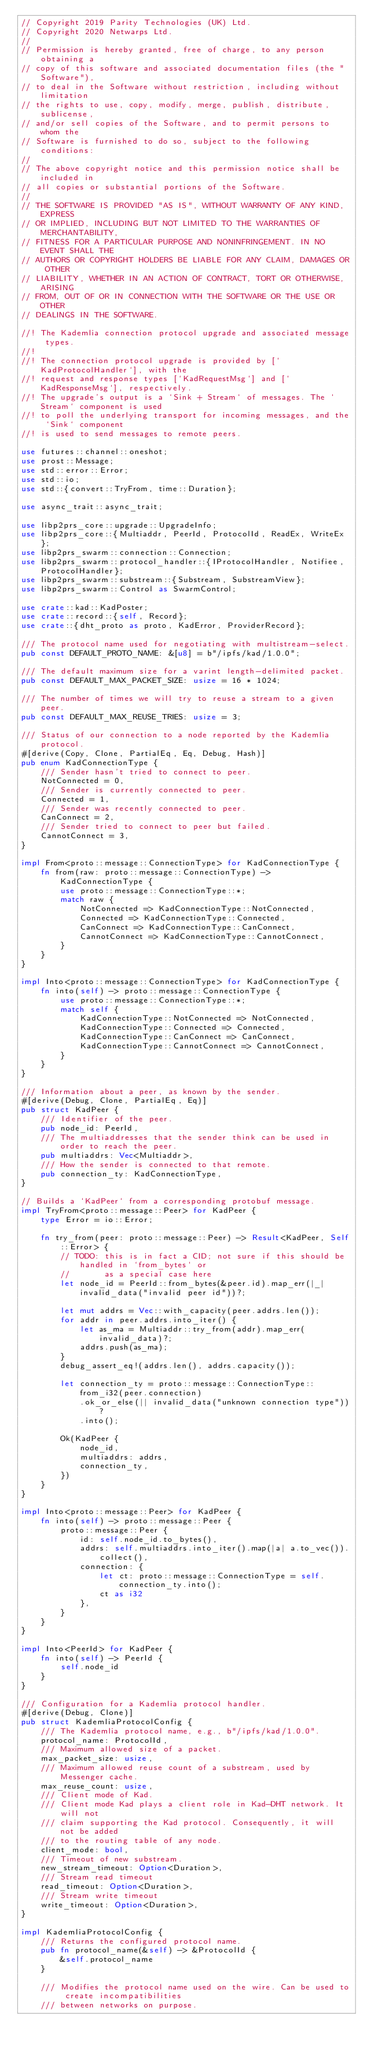<code> <loc_0><loc_0><loc_500><loc_500><_Rust_>// Copyright 2019 Parity Technologies (UK) Ltd.
// Copyright 2020 Netwarps Ltd.
//
// Permission is hereby granted, free of charge, to any person obtaining a
// copy of this software and associated documentation files (the "Software"),
// to deal in the Software without restriction, including without limitation
// the rights to use, copy, modify, merge, publish, distribute, sublicense,
// and/or sell copies of the Software, and to permit persons to whom the
// Software is furnished to do so, subject to the following conditions:
//
// The above copyright notice and this permission notice shall be included in
// all copies or substantial portions of the Software.
//
// THE SOFTWARE IS PROVIDED "AS IS", WITHOUT WARRANTY OF ANY KIND, EXPRESS
// OR IMPLIED, INCLUDING BUT NOT LIMITED TO THE WARRANTIES OF MERCHANTABILITY,
// FITNESS FOR A PARTICULAR PURPOSE AND NONINFRINGEMENT. IN NO EVENT SHALL THE
// AUTHORS OR COPYRIGHT HOLDERS BE LIABLE FOR ANY CLAIM, DAMAGES OR OTHER
// LIABILITY, WHETHER IN AN ACTION OF CONTRACT, TORT OR OTHERWISE, ARISING
// FROM, OUT OF OR IN CONNECTION WITH THE SOFTWARE OR THE USE OR OTHER
// DEALINGS IN THE SOFTWARE.

//! The Kademlia connection protocol upgrade and associated message types.
//!
//! The connection protocol upgrade is provided by [`KadProtocolHandler`], with the
//! request and response types [`KadRequestMsg`] and [`KadResponseMsg`], respectively.
//! The upgrade's output is a `Sink + Stream` of messages. The `Stream` component is used
//! to poll the underlying transport for incoming messages, and the `Sink` component
//! is used to send messages to remote peers.

use futures::channel::oneshot;
use prost::Message;
use std::error::Error;
use std::io;
use std::{convert::TryFrom, time::Duration};

use async_trait::async_trait;

use libp2prs_core::upgrade::UpgradeInfo;
use libp2prs_core::{Multiaddr, PeerId, ProtocolId, ReadEx, WriteEx};
use libp2prs_swarm::connection::Connection;
use libp2prs_swarm::protocol_handler::{IProtocolHandler, Notifiee, ProtocolHandler};
use libp2prs_swarm::substream::{Substream, SubstreamView};
use libp2prs_swarm::Control as SwarmControl;

use crate::kad::KadPoster;
use crate::record::{self, Record};
use crate::{dht_proto as proto, KadError, ProviderRecord};

/// The protocol name used for negotiating with multistream-select.
pub const DEFAULT_PROTO_NAME: &[u8] = b"/ipfs/kad/1.0.0";

/// The default maximum size for a varint length-delimited packet.
pub const DEFAULT_MAX_PACKET_SIZE: usize = 16 * 1024;

/// The number of times we will try to reuse a stream to a given peer.
pub const DEFAULT_MAX_REUSE_TRIES: usize = 3;

/// Status of our connection to a node reported by the Kademlia protocol.
#[derive(Copy, Clone, PartialEq, Eq, Debug, Hash)]
pub enum KadConnectionType {
    /// Sender hasn't tried to connect to peer.
    NotConnected = 0,
    /// Sender is currently connected to peer.
    Connected = 1,
    /// Sender was recently connected to peer.
    CanConnect = 2,
    /// Sender tried to connect to peer but failed.
    CannotConnect = 3,
}

impl From<proto::message::ConnectionType> for KadConnectionType {
    fn from(raw: proto::message::ConnectionType) -> KadConnectionType {
        use proto::message::ConnectionType::*;
        match raw {
            NotConnected => KadConnectionType::NotConnected,
            Connected => KadConnectionType::Connected,
            CanConnect => KadConnectionType::CanConnect,
            CannotConnect => KadConnectionType::CannotConnect,
        }
    }
}

impl Into<proto::message::ConnectionType> for KadConnectionType {
    fn into(self) -> proto::message::ConnectionType {
        use proto::message::ConnectionType::*;
        match self {
            KadConnectionType::NotConnected => NotConnected,
            KadConnectionType::Connected => Connected,
            KadConnectionType::CanConnect => CanConnect,
            KadConnectionType::CannotConnect => CannotConnect,
        }
    }
}

/// Information about a peer, as known by the sender.
#[derive(Debug, Clone, PartialEq, Eq)]
pub struct KadPeer {
    /// Identifier of the peer.
    pub node_id: PeerId,
    /// The multiaddresses that the sender think can be used in order to reach the peer.
    pub multiaddrs: Vec<Multiaddr>,
    /// How the sender is connected to that remote.
    pub connection_ty: KadConnectionType,
}

// Builds a `KadPeer` from a corresponding protobuf message.
impl TryFrom<proto::message::Peer> for KadPeer {
    type Error = io::Error;

    fn try_from(peer: proto::message::Peer) -> Result<KadPeer, Self::Error> {
        // TODO: this is in fact a CID; not sure if this should be handled in `from_bytes` or
        //       as a special case here
        let node_id = PeerId::from_bytes(&peer.id).map_err(|_| invalid_data("invalid peer id"))?;

        let mut addrs = Vec::with_capacity(peer.addrs.len());
        for addr in peer.addrs.into_iter() {
            let as_ma = Multiaddr::try_from(addr).map_err(invalid_data)?;
            addrs.push(as_ma);
        }
        debug_assert_eq!(addrs.len(), addrs.capacity());

        let connection_ty = proto::message::ConnectionType::from_i32(peer.connection)
            .ok_or_else(|| invalid_data("unknown connection type"))?
            .into();

        Ok(KadPeer {
            node_id,
            multiaddrs: addrs,
            connection_ty,
        })
    }
}

impl Into<proto::message::Peer> for KadPeer {
    fn into(self) -> proto::message::Peer {
        proto::message::Peer {
            id: self.node_id.to_bytes(),
            addrs: self.multiaddrs.into_iter().map(|a| a.to_vec()).collect(),
            connection: {
                let ct: proto::message::ConnectionType = self.connection_ty.into();
                ct as i32
            },
        }
    }
}

impl Into<PeerId> for KadPeer {
    fn into(self) -> PeerId {
        self.node_id
    }
}

/// Configuration for a Kademlia protocol handler.
#[derive(Debug, Clone)]
pub struct KademliaProtocolConfig {
    /// The Kademlia protocol name, e.g., b"/ipfs/kad/1.0.0".
    protocol_name: ProtocolId,
    /// Maximum allowed size of a packet.
    max_packet_size: usize,
    /// Maximum allowed reuse count of a substream, used by Messenger cache.
    max_reuse_count: usize,
    /// Client mode of Kad.
    /// Client mode Kad plays a client role in Kad-DHT network. It will not
    /// claim supporting the Kad protocol. Consequently, it will not be added
    /// to the routing table of any node.
    client_mode: bool,
    /// Timeout of new substream.
    new_stream_timeout: Option<Duration>,
    /// Stream read timeout
    read_timeout: Option<Duration>,
    /// Stream write timeout
    write_timeout: Option<Duration>,
}

impl KademliaProtocolConfig {
    /// Returns the configured protocol name.
    pub fn protocol_name(&self) -> &ProtocolId {
        &self.protocol_name
    }

    /// Modifies the protocol name used on the wire. Can be used to create incompatibilities
    /// between networks on purpose.</code> 